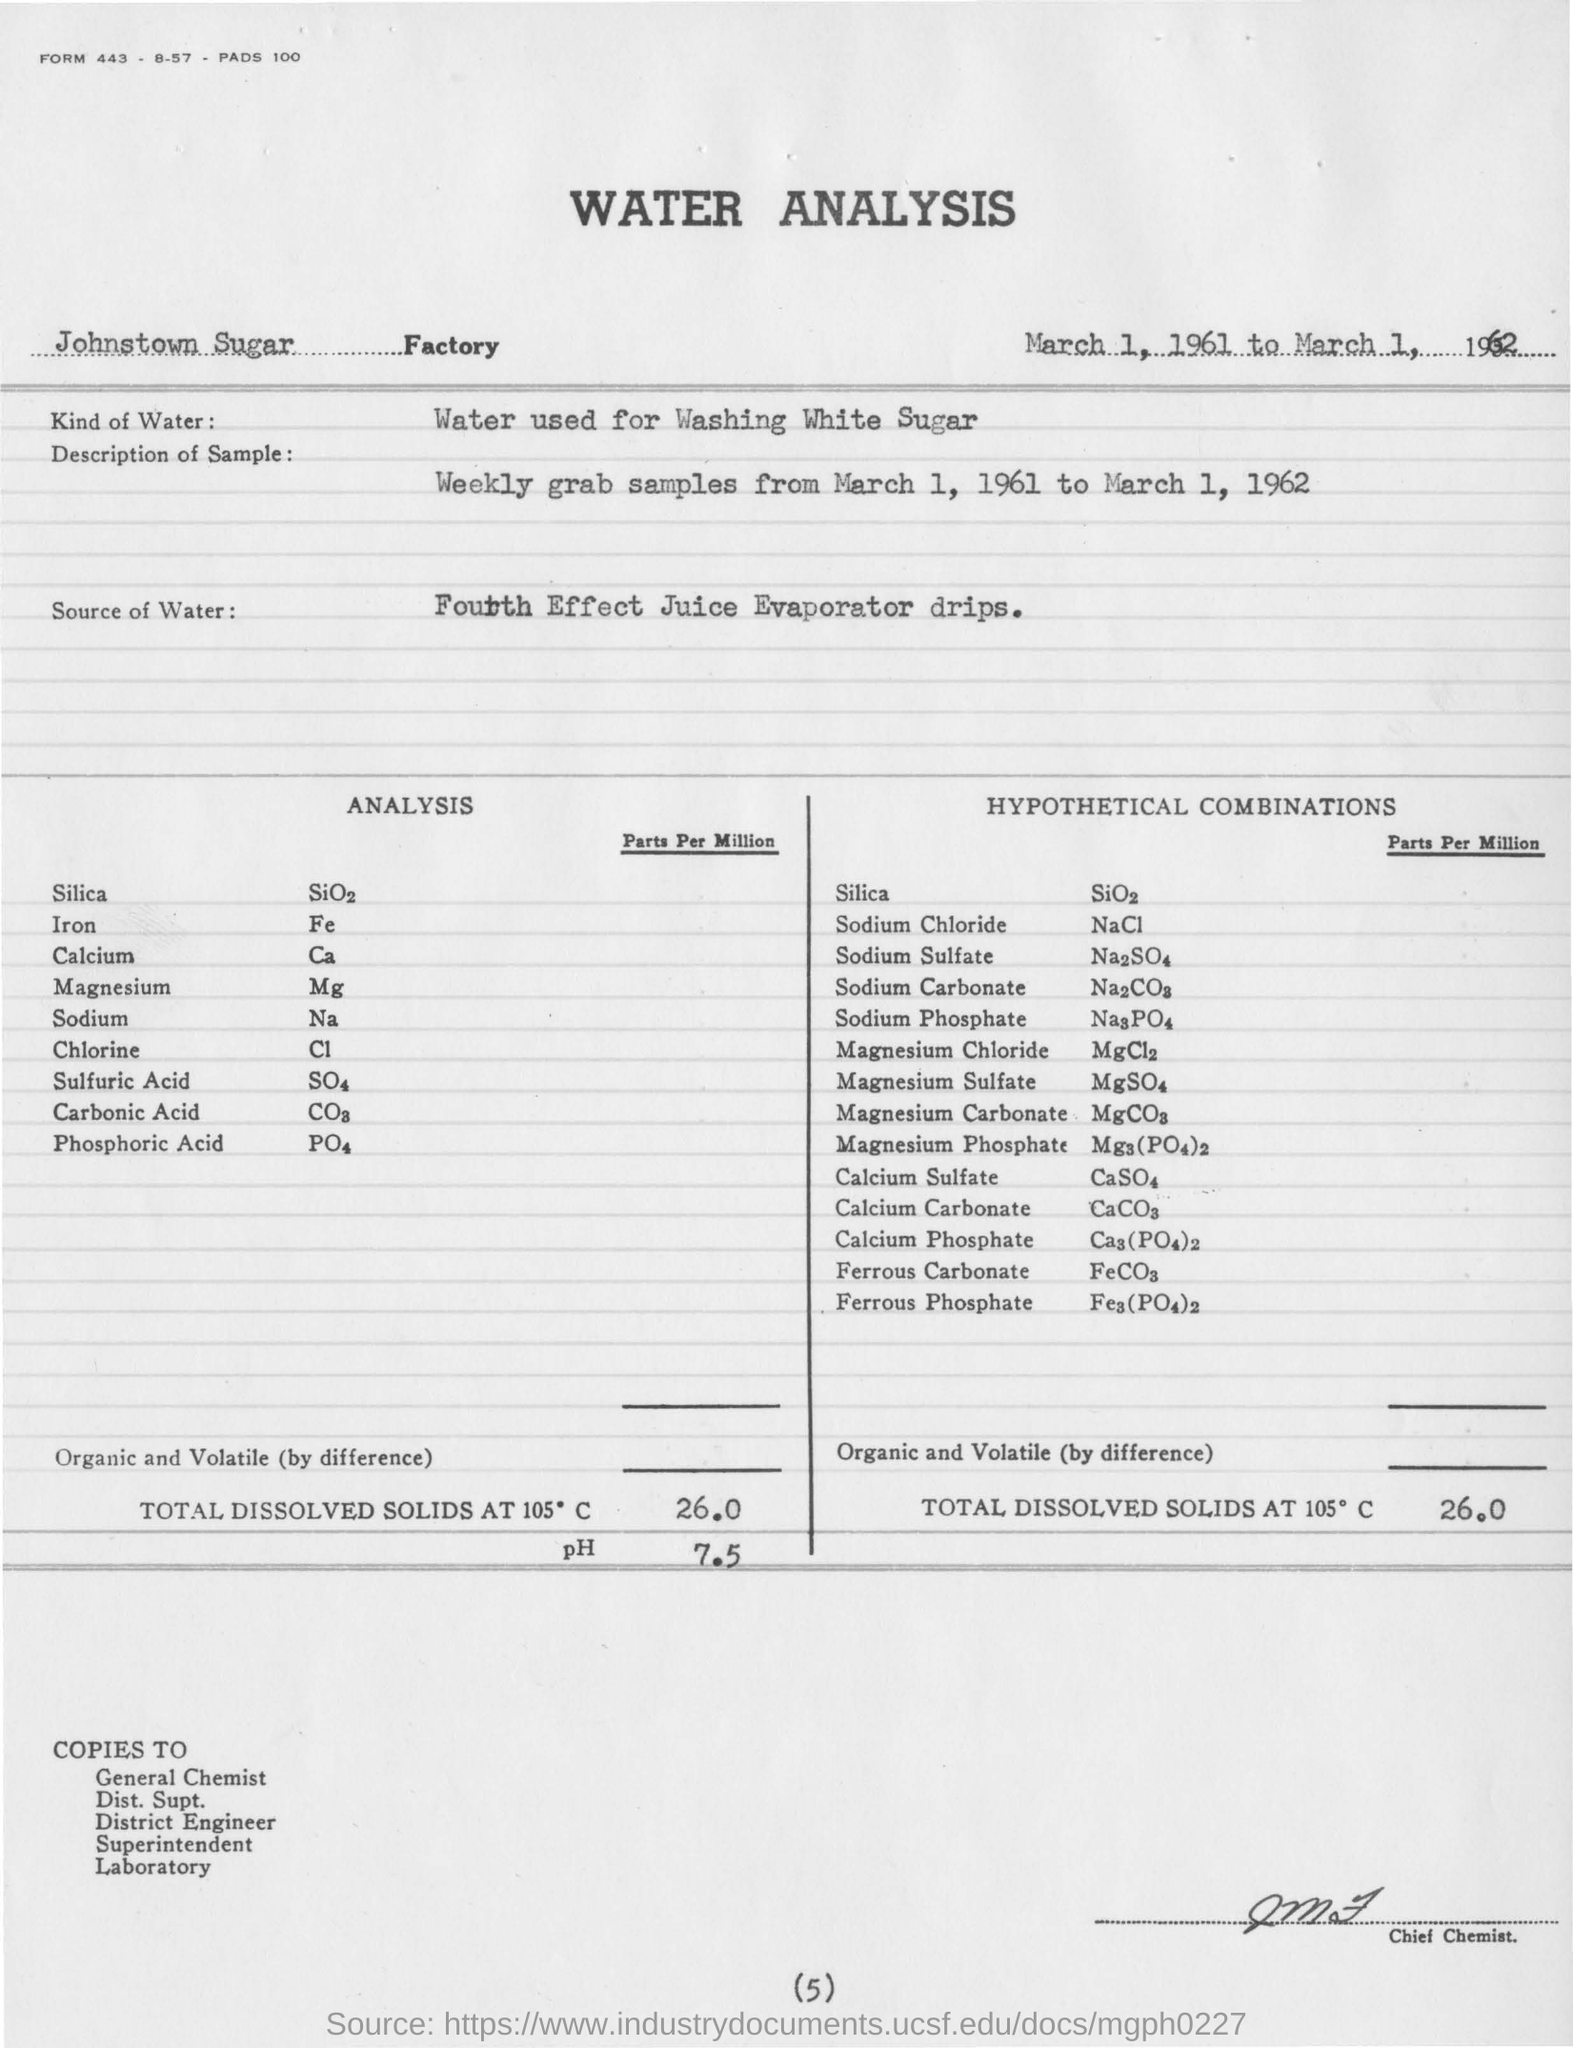Which sugar factory is mentioned?
Your answer should be compact. Johnstown Sugar Factory. What is the water used in the analysis?
Offer a terse response. Water used for washing white sugar. What is the source of water?
Make the answer very short. Fourth Effect Juice evaporator drips. When was the analysis done?
Offer a terse response. March 1, 1961 to March 1, 1962. 